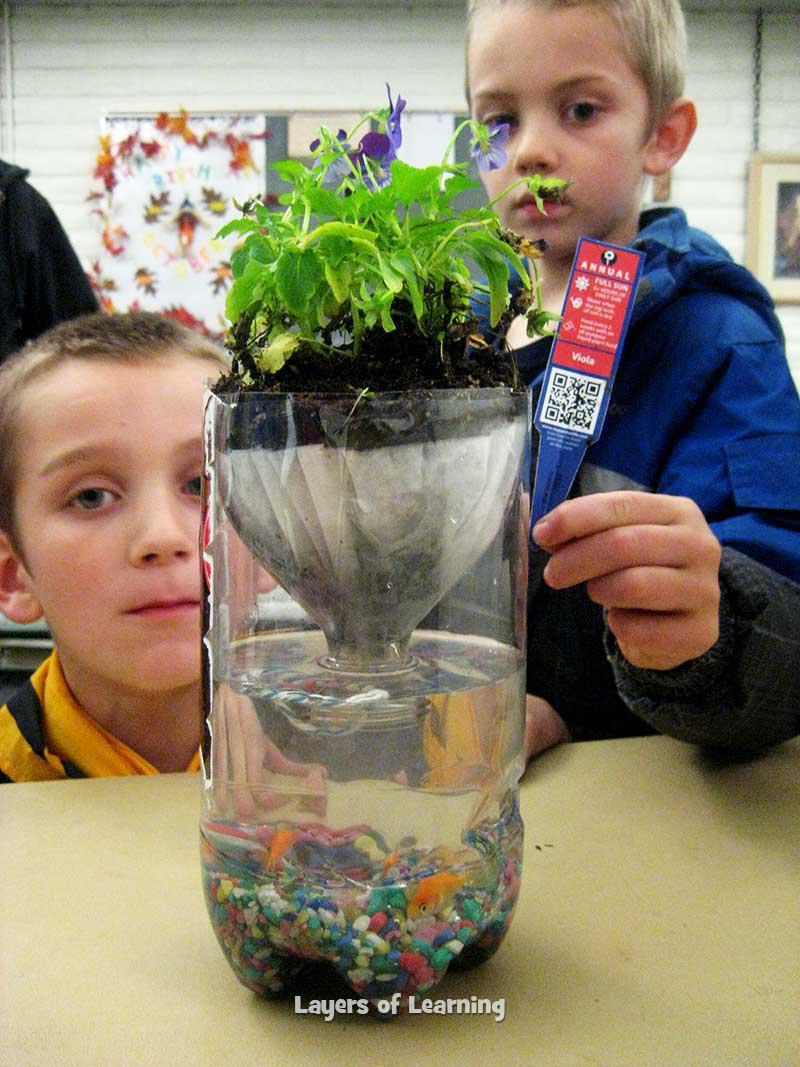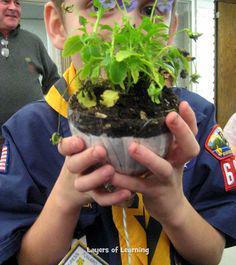The first image is the image on the left, the second image is the image on the right. Given the left and right images, does the statement "One person is holding a plant." hold true? Answer yes or no. Yes. The first image is the image on the left, the second image is the image on the right. For the images shown, is this caption "In one image a boy in a uniform is holding up a green plant in front of him with both hands." true? Answer yes or no. Yes. 